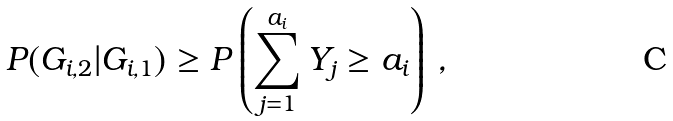Convert formula to latex. <formula><loc_0><loc_0><loc_500><loc_500>P ( G _ { i , 2 } | G _ { i , 1 } ) \geq P \left ( \sum _ { j = 1 } ^ { a _ { i } } Y _ { j } \geq a _ { i } \right ) \, ,</formula> 